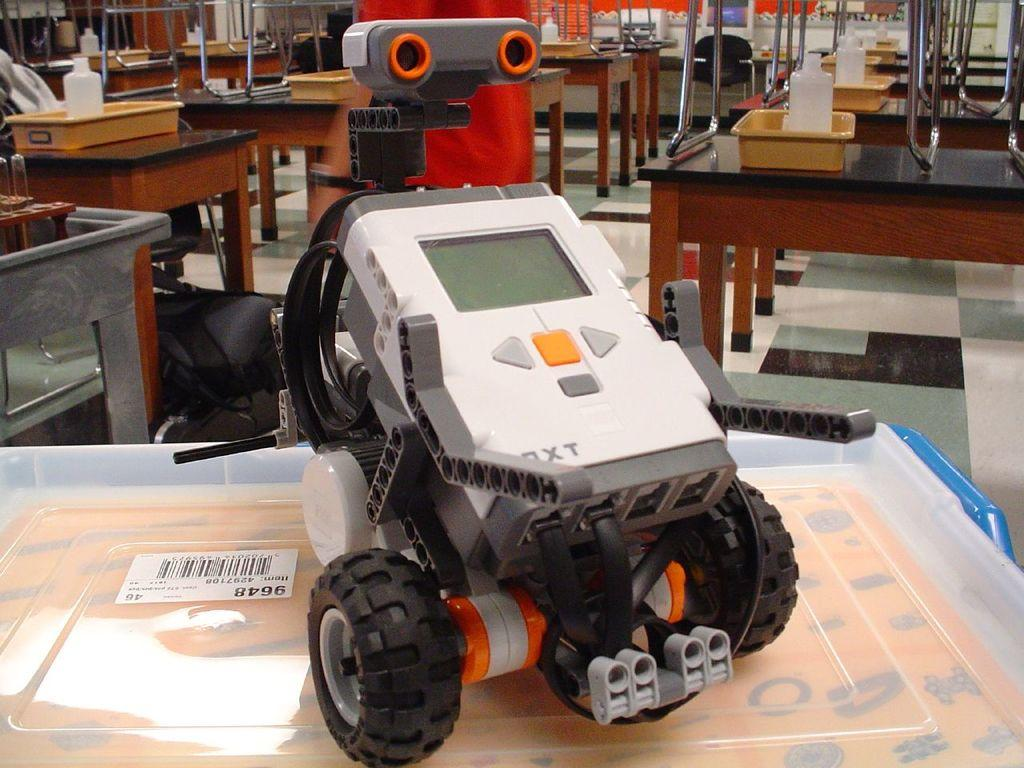What type of furniture is present in the image? There are tables in the image. Can you describe the objects on the tables? There is a tray on one of the tables, and it has a bottle on it. What other item can be seen in the image? There is a toy vehicle in the image. How many police officers are present in the image? There are no police officers present in the image. What type of cart is being used to transport the toy vehicle in the image? There is no cart present in the image; the toy vehicle is not being transported. 